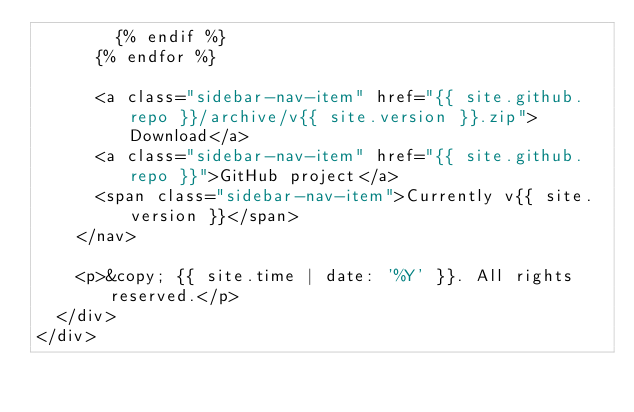Convert code to text. <code><loc_0><loc_0><loc_500><loc_500><_HTML_>        {% endif %}
      {% endfor %}

      <a class="sidebar-nav-item" href="{{ site.github.repo }}/archive/v{{ site.version }}.zip">Download</a>
      <a class="sidebar-nav-item" href="{{ site.github.repo }}">GitHub project</a>
      <span class="sidebar-nav-item">Currently v{{ site.version }}</span>
    </nav>

    <p>&copy; {{ site.time | date: '%Y' }}. All rights reserved.</p>
  </div>
</div>
</code> 